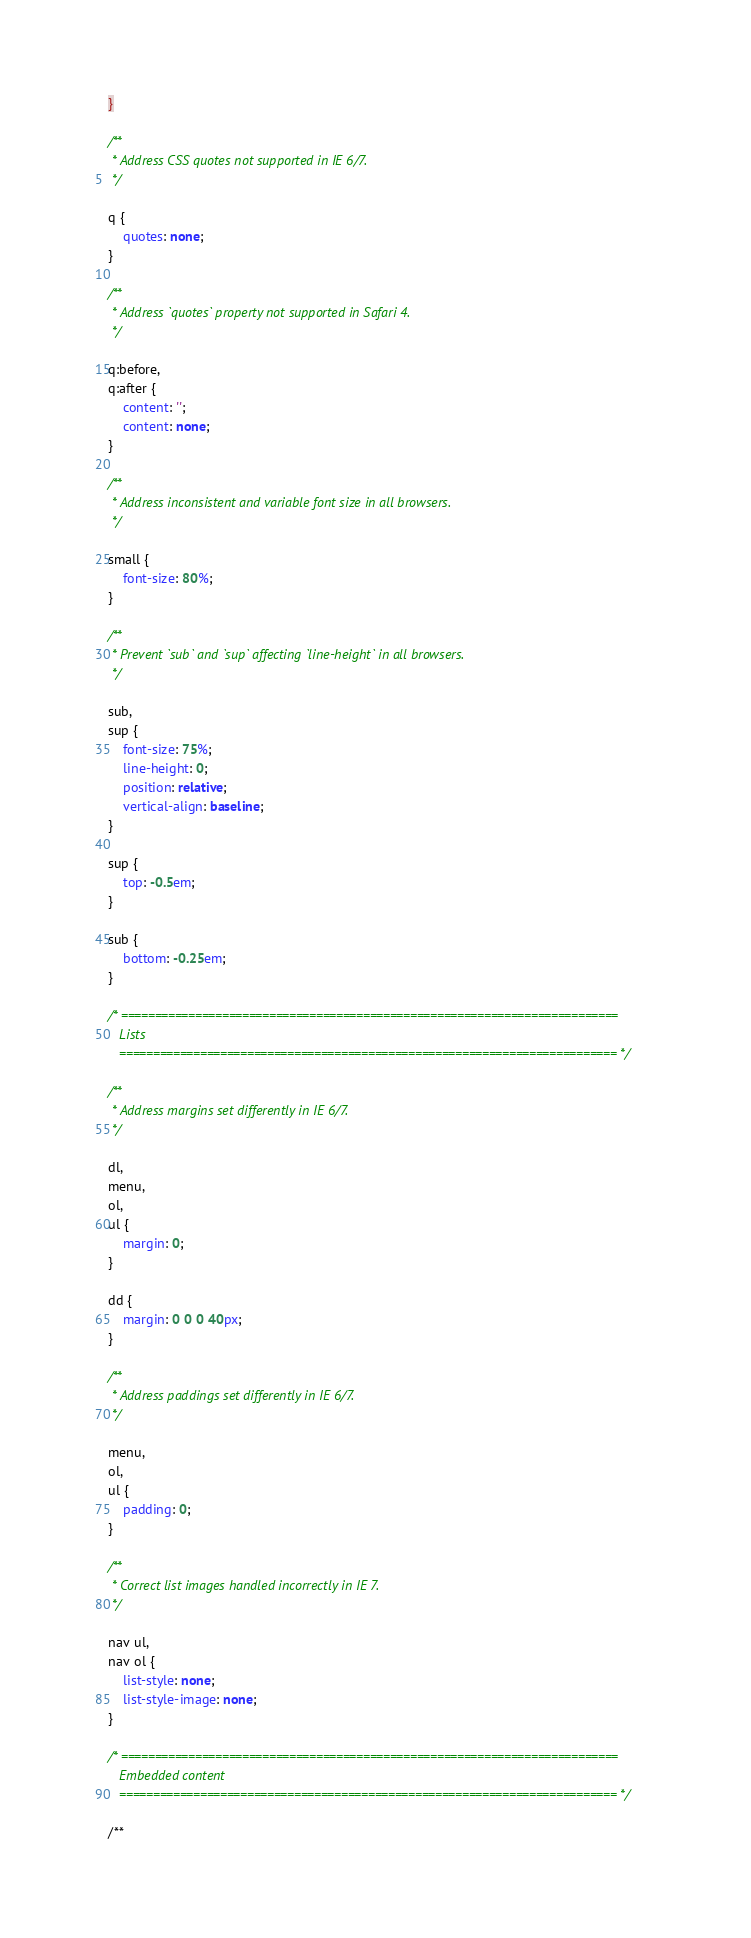<code> <loc_0><loc_0><loc_500><loc_500><_CSS_>}

/**
 * Address CSS quotes not supported in IE 6/7.
 */

q {
    quotes: none;
}

/**
 * Address `quotes` property not supported in Safari 4.
 */

q:before,
q:after {
    content: '';
    content: none;
}

/**
 * Address inconsistent and variable font size in all browsers.
 */

small {
    font-size: 80%;
}

/**
 * Prevent `sub` and `sup` affecting `line-height` in all browsers.
 */

sub,
sup {
    font-size: 75%;
    line-height: 0;
    position: relative;
    vertical-align: baseline;
}

sup {
    top: -0.5em;
}

sub {
    bottom: -0.25em;
}

/* ==========================================================================
   Lists
   ========================================================================== */

/**
 * Address margins set differently in IE 6/7.
 */

dl,
menu,
ol,
ul {
    margin: 0;
}

dd {
    margin: 0 0 0 40px;
}

/**
 * Address paddings set differently in IE 6/7.
 */

menu,
ol,
ul {
    padding: 0;
}

/**
 * Correct list images handled incorrectly in IE 7.
 */

nav ul,
nav ol {
    list-style: none;
    list-style-image: none;
}

/* ==========================================================================
   Embedded content
   ========================================================================== */

/**</code> 